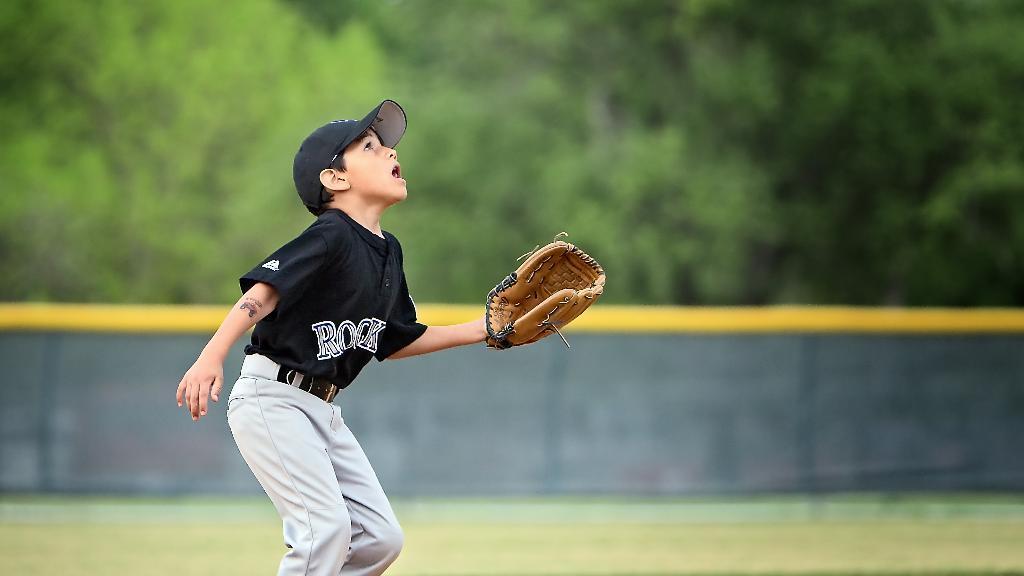Describe this image in one or two sentences. In this image I see a boy who is wearing black color t-shirt and grey pants and I see that he is wearing a cap and a glove and I see that it is blurred in the background and I see that there are number of trees over here. 